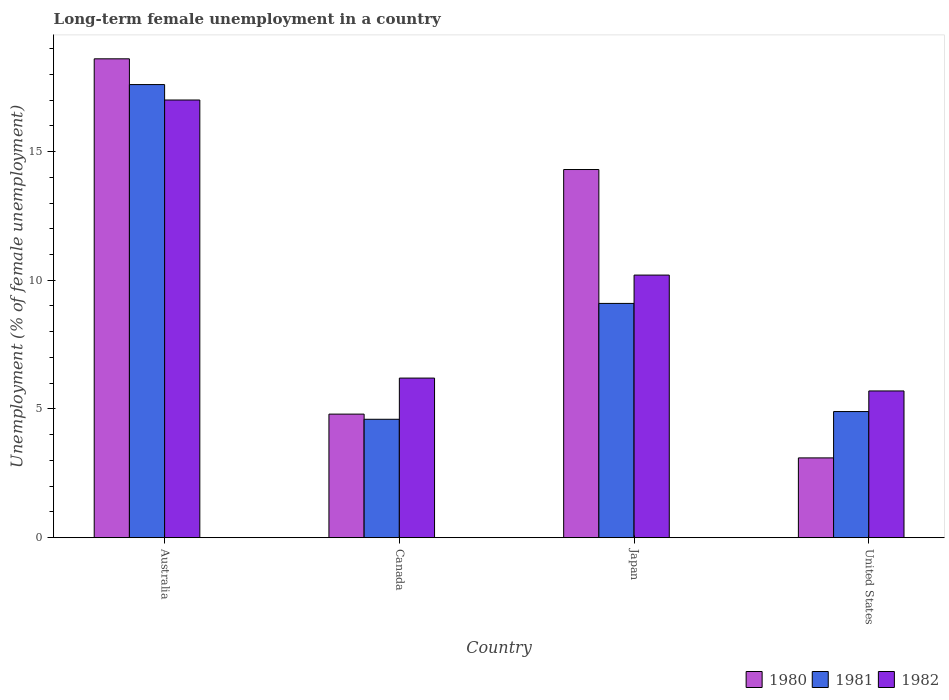Are the number of bars on each tick of the X-axis equal?
Your response must be concise. Yes. How many bars are there on the 4th tick from the left?
Keep it short and to the point. 3. What is the label of the 3rd group of bars from the left?
Your answer should be compact. Japan. In how many cases, is the number of bars for a given country not equal to the number of legend labels?
Keep it short and to the point. 0. Across all countries, what is the maximum percentage of long-term unemployed female population in 1982?
Keep it short and to the point. 17. Across all countries, what is the minimum percentage of long-term unemployed female population in 1981?
Make the answer very short. 4.6. In which country was the percentage of long-term unemployed female population in 1982 maximum?
Offer a terse response. Australia. In which country was the percentage of long-term unemployed female population in 1982 minimum?
Your answer should be compact. United States. What is the total percentage of long-term unemployed female population in 1980 in the graph?
Offer a terse response. 40.8. What is the difference between the percentage of long-term unemployed female population in 1982 in Canada and that in Japan?
Offer a terse response. -4. What is the difference between the percentage of long-term unemployed female population in 1980 in Japan and the percentage of long-term unemployed female population in 1981 in Canada?
Provide a short and direct response. 9.7. What is the average percentage of long-term unemployed female population in 1982 per country?
Give a very brief answer. 9.77. What is the difference between the percentage of long-term unemployed female population of/in 1982 and percentage of long-term unemployed female population of/in 1980 in United States?
Your answer should be compact. 2.6. In how many countries, is the percentage of long-term unemployed female population in 1981 greater than 14 %?
Ensure brevity in your answer.  1. What is the ratio of the percentage of long-term unemployed female population in 1982 in Australia to that in Canada?
Offer a very short reply. 2.74. Is the percentage of long-term unemployed female population in 1981 in Australia less than that in Canada?
Provide a succinct answer. No. What is the difference between the highest and the second highest percentage of long-term unemployed female population in 1980?
Offer a terse response. 13.8. What is the difference between the highest and the lowest percentage of long-term unemployed female population in 1980?
Your response must be concise. 15.5. In how many countries, is the percentage of long-term unemployed female population in 1982 greater than the average percentage of long-term unemployed female population in 1982 taken over all countries?
Your response must be concise. 2. Is the sum of the percentage of long-term unemployed female population in 1981 in Canada and Japan greater than the maximum percentage of long-term unemployed female population in 1982 across all countries?
Provide a short and direct response. No. What does the 2nd bar from the left in United States represents?
Provide a short and direct response. 1981. What does the 3rd bar from the right in Japan represents?
Ensure brevity in your answer.  1980. Are the values on the major ticks of Y-axis written in scientific E-notation?
Provide a short and direct response. No. Does the graph contain grids?
Give a very brief answer. No. Where does the legend appear in the graph?
Your response must be concise. Bottom right. How many legend labels are there?
Your answer should be compact. 3. How are the legend labels stacked?
Ensure brevity in your answer.  Horizontal. What is the title of the graph?
Give a very brief answer. Long-term female unemployment in a country. What is the label or title of the Y-axis?
Your response must be concise. Unemployment (% of female unemployment). What is the Unemployment (% of female unemployment) of 1980 in Australia?
Offer a very short reply. 18.6. What is the Unemployment (% of female unemployment) in 1981 in Australia?
Offer a terse response. 17.6. What is the Unemployment (% of female unemployment) in 1980 in Canada?
Offer a very short reply. 4.8. What is the Unemployment (% of female unemployment) of 1981 in Canada?
Ensure brevity in your answer.  4.6. What is the Unemployment (% of female unemployment) in 1982 in Canada?
Ensure brevity in your answer.  6.2. What is the Unemployment (% of female unemployment) in 1980 in Japan?
Your answer should be compact. 14.3. What is the Unemployment (% of female unemployment) in 1981 in Japan?
Your answer should be compact. 9.1. What is the Unemployment (% of female unemployment) of 1982 in Japan?
Your answer should be very brief. 10.2. What is the Unemployment (% of female unemployment) of 1980 in United States?
Ensure brevity in your answer.  3.1. What is the Unemployment (% of female unemployment) in 1981 in United States?
Make the answer very short. 4.9. What is the Unemployment (% of female unemployment) in 1982 in United States?
Make the answer very short. 5.7. Across all countries, what is the maximum Unemployment (% of female unemployment) in 1980?
Your response must be concise. 18.6. Across all countries, what is the maximum Unemployment (% of female unemployment) of 1981?
Your response must be concise. 17.6. Across all countries, what is the maximum Unemployment (% of female unemployment) in 1982?
Ensure brevity in your answer.  17. Across all countries, what is the minimum Unemployment (% of female unemployment) in 1980?
Give a very brief answer. 3.1. Across all countries, what is the minimum Unemployment (% of female unemployment) in 1981?
Give a very brief answer. 4.6. Across all countries, what is the minimum Unemployment (% of female unemployment) of 1982?
Offer a terse response. 5.7. What is the total Unemployment (% of female unemployment) of 1980 in the graph?
Your answer should be very brief. 40.8. What is the total Unemployment (% of female unemployment) of 1981 in the graph?
Make the answer very short. 36.2. What is the total Unemployment (% of female unemployment) of 1982 in the graph?
Offer a terse response. 39.1. What is the difference between the Unemployment (% of female unemployment) of 1981 in Australia and that in Canada?
Offer a very short reply. 13. What is the difference between the Unemployment (% of female unemployment) of 1982 in Australia and that in Canada?
Your response must be concise. 10.8. What is the difference between the Unemployment (% of female unemployment) of 1980 in Australia and that in United States?
Keep it short and to the point. 15.5. What is the difference between the Unemployment (% of female unemployment) of 1982 in Australia and that in United States?
Offer a terse response. 11.3. What is the difference between the Unemployment (% of female unemployment) of 1980 in Canada and that in Japan?
Provide a short and direct response. -9.5. What is the difference between the Unemployment (% of female unemployment) of 1980 in Canada and that in United States?
Offer a terse response. 1.7. What is the difference between the Unemployment (% of female unemployment) of 1982 in Canada and that in United States?
Your answer should be very brief. 0.5. What is the difference between the Unemployment (% of female unemployment) in 1981 in Japan and that in United States?
Offer a terse response. 4.2. What is the difference between the Unemployment (% of female unemployment) in 1982 in Japan and that in United States?
Provide a short and direct response. 4.5. What is the difference between the Unemployment (% of female unemployment) in 1980 in Australia and the Unemployment (% of female unemployment) in 1982 in Canada?
Give a very brief answer. 12.4. What is the difference between the Unemployment (% of female unemployment) in 1980 in Australia and the Unemployment (% of female unemployment) in 1981 in Japan?
Your answer should be compact. 9.5. What is the difference between the Unemployment (% of female unemployment) in 1980 in Australia and the Unemployment (% of female unemployment) in 1982 in Japan?
Keep it short and to the point. 8.4. What is the difference between the Unemployment (% of female unemployment) in 1980 in Australia and the Unemployment (% of female unemployment) in 1982 in United States?
Offer a very short reply. 12.9. What is the difference between the Unemployment (% of female unemployment) in 1981 in Canada and the Unemployment (% of female unemployment) in 1982 in Japan?
Keep it short and to the point. -5.6. What is the difference between the Unemployment (% of female unemployment) in 1980 in Canada and the Unemployment (% of female unemployment) in 1981 in United States?
Provide a succinct answer. -0.1. What is the difference between the Unemployment (% of female unemployment) in 1980 in Japan and the Unemployment (% of female unemployment) in 1982 in United States?
Ensure brevity in your answer.  8.6. What is the difference between the Unemployment (% of female unemployment) in 1981 in Japan and the Unemployment (% of female unemployment) in 1982 in United States?
Your response must be concise. 3.4. What is the average Unemployment (% of female unemployment) of 1980 per country?
Make the answer very short. 10.2. What is the average Unemployment (% of female unemployment) in 1981 per country?
Ensure brevity in your answer.  9.05. What is the average Unemployment (% of female unemployment) of 1982 per country?
Provide a succinct answer. 9.78. What is the difference between the Unemployment (% of female unemployment) of 1980 and Unemployment (% of female unemployment) of 1981 in Australia?
Keep it short and to the point. 1. What is the difference between the Unemployment (% of female unemployment) in 1980 and Unemployment (% of female unemployment) in 1982 in Australia?
Your response must be concise. 1.6. What is the difference between the Unemployment (% of female unemployment) in 1980 and Unemployment (% of female unemployment) in 1981 in Canada?
Your response must be concise. 0.2. What is the difference between the Unemployment (% of female unemployment) in 1981 and Unemployment (% of female unemployment) in 1982 in Canada?
Your answer should be compact. -1.6. What is the difference between the Unemployment (% of female unemployment) in 1981 and Unemployment (% of female unemployment) in 1982 in Japan?
Make the answer very short. -1.1. What is the difference between the Unemployment (% of female unemployment) in 1980 and Unemployment (% of female unemployment) in 1981 in United States?
Keep it short and to the point. -1.8. What is the difference between the Unemployment (% of female unemployment) of 1980 and Unemployment (% of female unemployment) of 1982 in United States?
Offer a very short reply. -2.6. What is the ratio of the Unemployment (% of female unemployment) of 1980 in Australia to that in Canada?
Your answer should be very brief. 3.88. What is the ratio of the Unemployment (% of female unemployment) in 1981 in Australia to that in Canada?
Offer a terse response. 3.83. What is the ratio of the Unemployment (% of female unemployment) in 1982 in Australia to that in Canada?
Offer a very short reply. 2.74. What is the ratio of the Unemployment (% of female unemployment) in 1980 in Australia to that in Japan?
Give a very brief answer. 1.3. What is the ratio of the Unemployment (% of female unemployment) in 1981 in Australia to that in Japan?
Provide a succinct answer. 1.93. What is the ratio of the Unemployment (% of female unemployment) of 1980 in Australia to that in United States?
Your response must be concise. 6. What is the ratio of the Unemployment (% of female unemployment) in 1981 in Australia to that in United States?
Ensure brevity in your answer.  3.59. What is the ratio of the Unemployment (% of female unemployment) in 1982 in Australia to that in United States?
Keep it short and to the point. 2.98. What is the ratio of the Unemployment (% of female unemployment) of 1980 in Canada to that in Japan?
Your response must be concise. 0.34. What is the ratio of the Unemployment (% of female unemployment) in 1981 in Canada to that in Japan?
Ensure brevity in your answer.  0.51. What is the ratio of the Unemployment (% of female unemployment) of 1982 in Canada to that in Japan?
Give a very brief answer. 0.61. What is the ratio of the Unemployment (% of female unemployment) of 1980 in Canada to that in United States?
Your answer should be very brief. 1.55. What is the ratio of the Unemployment (% of female unemployment) of 1981 in Canada to that in United States?
Make the answer very short. 0.94. What is the ratio of the Unemployment (% of female unemployment) in 1982 in Canada to that in United States?
Ensure brevity in your answer.  1.09. What is the ratio of the Unemployment (% of female unemployment) in 1980 in Japan to that in United States?
Provide a succinct answer. 4.61. What is the ratio of the Unemployment (% of female unemployment) of 1981 in Japan to that in United States?
Keep it short and to the point. 1.86. What is the ratio of the Unemployment (% of female unemployment) of 1982 in Japan to that in United States?
Keep it short and to the point. 1.79. What is the difference between the highest and the second highest Unemployment (% of female unemployment) of 1980?
Keep it short and to the point. 4.3. What is the difference between the highest and the second highest Unemployment (% of female unemployment) of 1981?
Offer a very short reply. 8.5. What is the difference between the highest and the second highest Unemployment (% of female unemployment) of 1982?
Ensure brevity in your answer.  6.8. What is the difference between the highest and the lowest Unemployment (% of female unemployment) of 1982?
Provide a short and direct response. 11.3. 